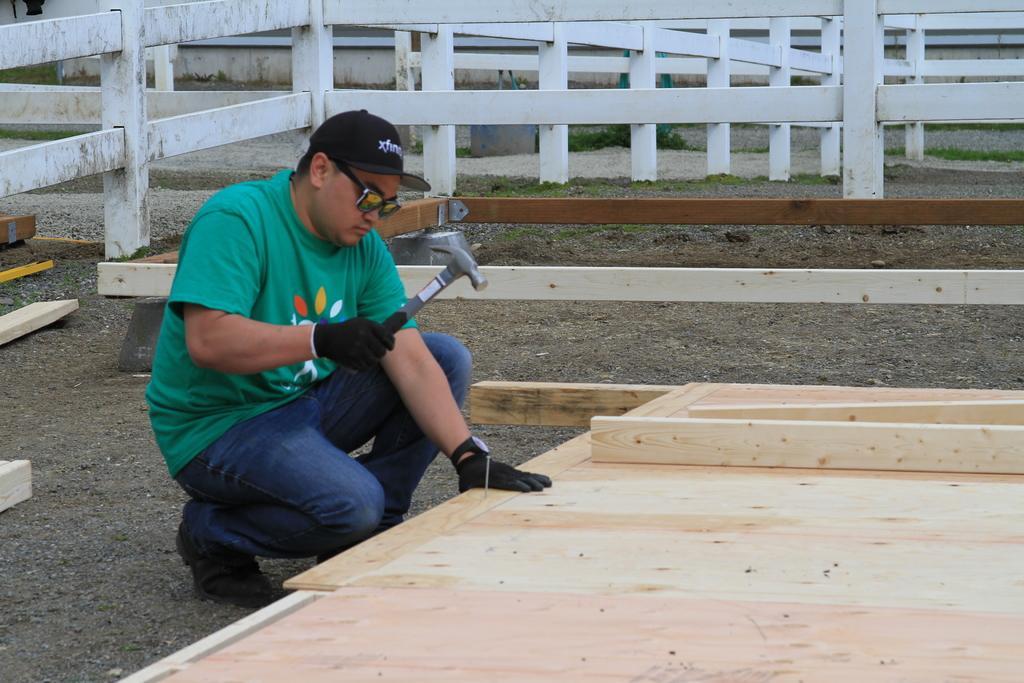Describe this image in one or two sentences. In this image, we can see a man sitting and holding a hammer, we can see the wooden seat. In the background, we can see the fencing. 